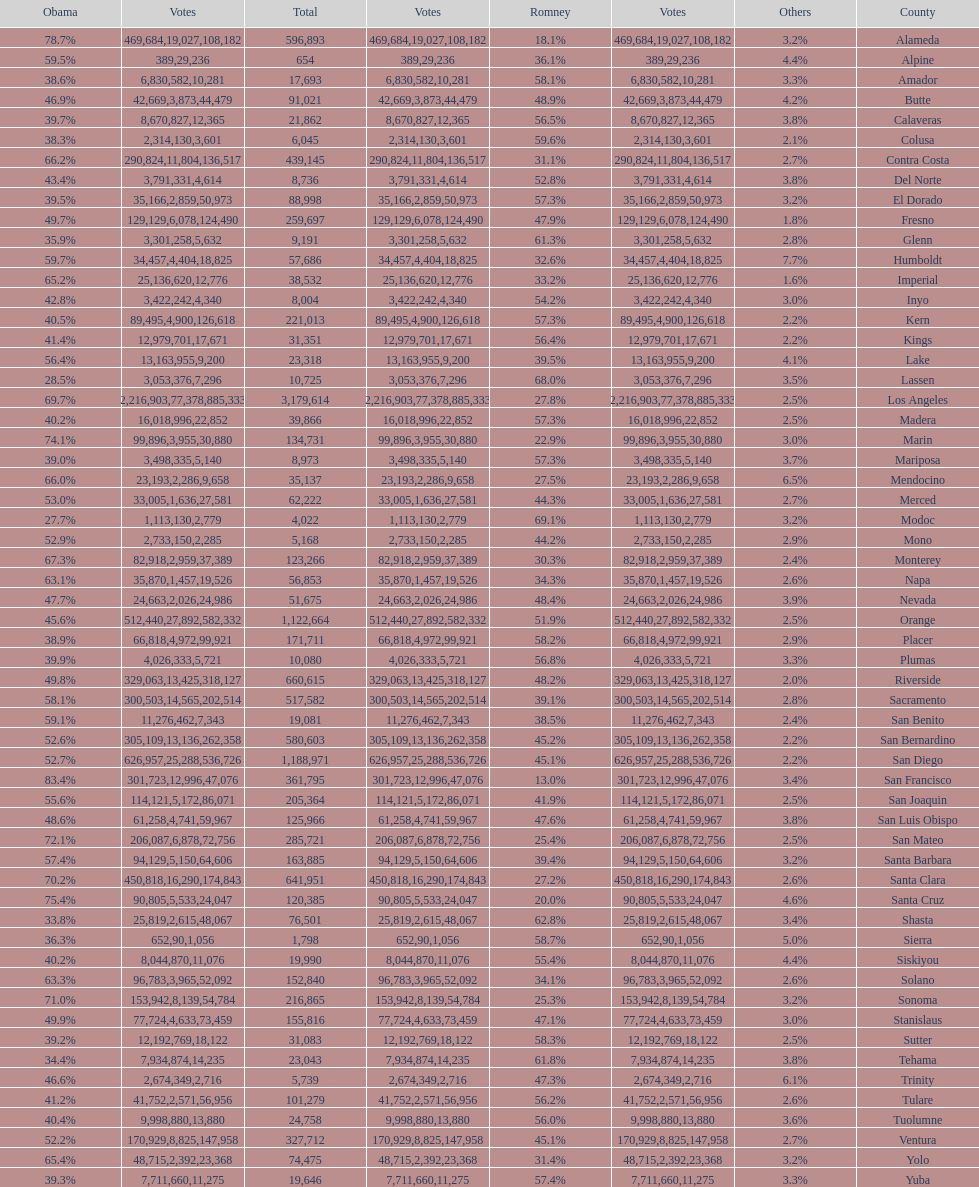What is the total number of votes for amador? 17693. 